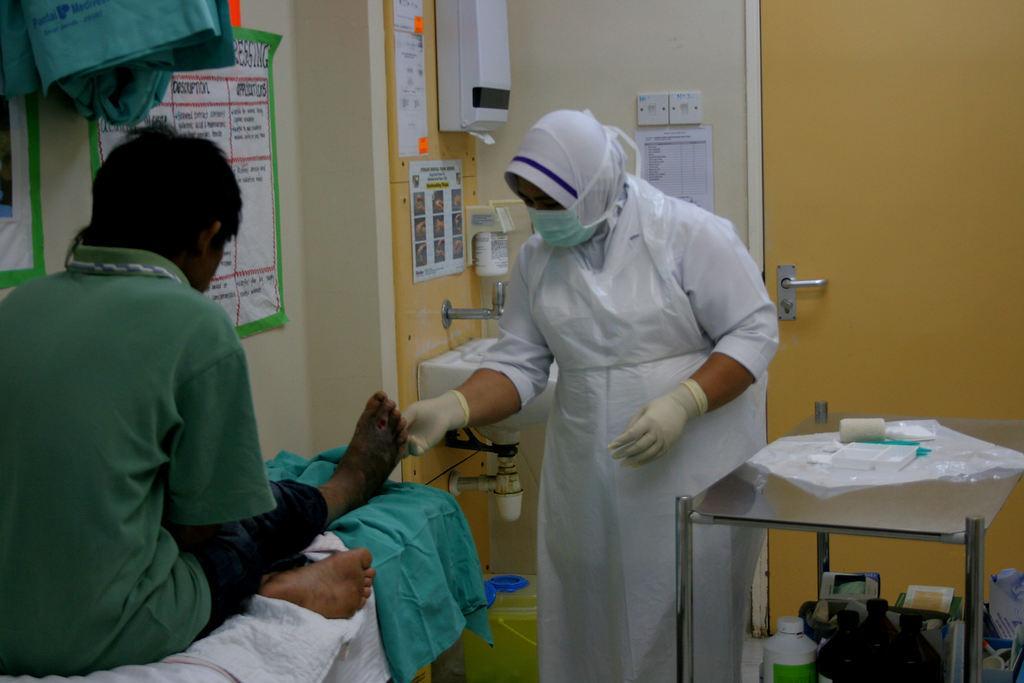Describe this image in one or two sentences. In this image there is a person sitting on the bed. There is a nurse. There is a table. There are papers on the table and bottles in the table. There is a wall. There are papers on the wall. There is a door. 